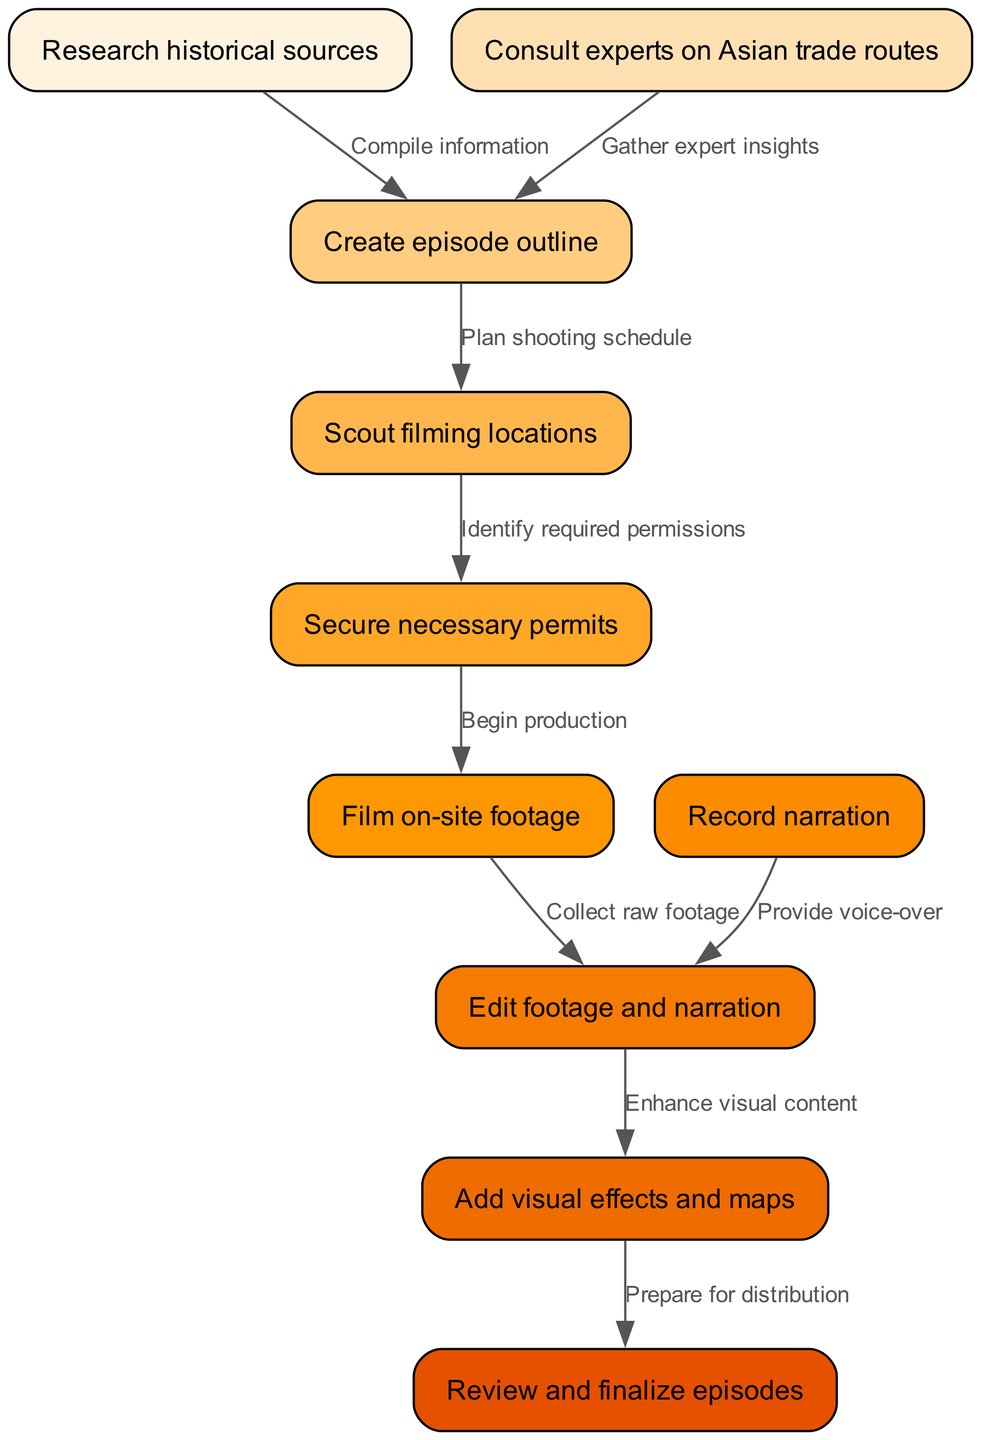What is the first step in creating the documentary series? The diagram indicates that the first step is "Research historical sources". This is shown as the starting node, leading to subsequent actions.
Answer: Research historical sources How many nodes are there in the diagram? By counting the nodes listed in the diagram, there are a total of ten distinct steps involved in the documentary workflow.
Answer: Ten What is the relationship between "Scout filming locations" and "Secure necessary permits"? The diagram shows that "Scout filming locations" leads to "Secure necessary permits", indicating that scouting is necessary before permits can be secured.
Answer: Identify required permissions Which step follows "Edit footage and narration"? The diagram indicates that the step that follows "Edit footage and narration" is "Add visual effects and maps". This follows the typical sequence of post-production tasks.
Answer: Add visual effects and maps How many edges connect the nodes? The diagram has nine edges that show the connections between the various steps in the workflow of creating the documentary series, representing the flow of control.
Answer: Nine What steps must be completed before filming on-site footage? Before filming on-site footage, "Create episode outline" must be completed first, followed by "Scout filming locations" and "Secure necessary permits". This sequence is necessary for production readiness.
Answer: Create episode outline, Scout filming locations, Secure necessary permits Which node provides voice-over? The diagram shows that the node "Record narration" is the step that involves providing voice-over for the documentary series.
Answer: Record narration What is the final step in the workflow? According to the diagram, the final step in the workflow is "Review and finalize episodes", which concludes the production process before distribution.
Answer: Review and finalize episodes What does the edge from "Research historical sources" to "Create episode outline" signify? The edge indicates that after information is compiled from researching historical sources, it directly contributes to the creation of the episode outline, showing a logical progression.
Answer: Compile information 